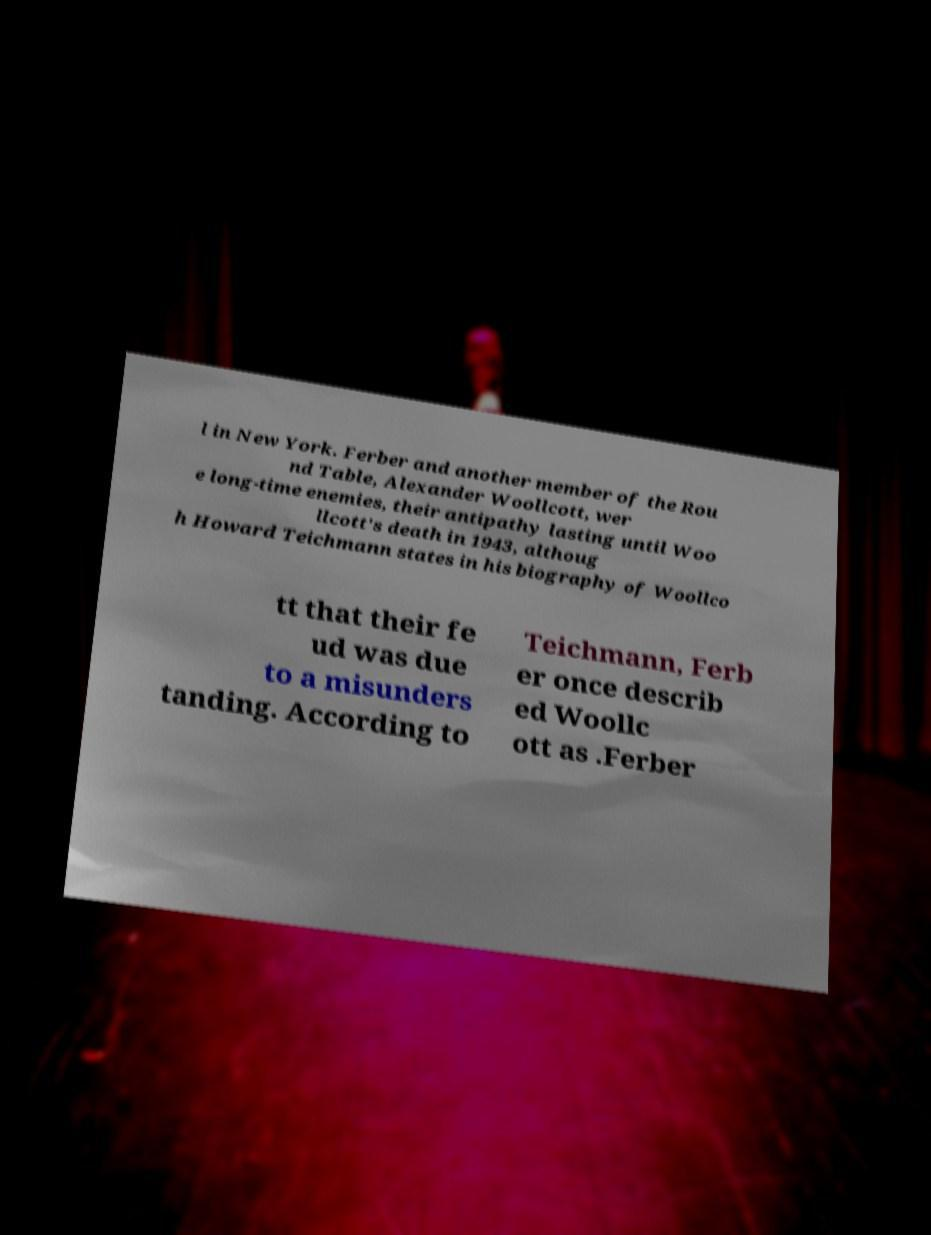Please read and relay the text visible in this image. What does it say? l in New York. Ferber and another member of the Rou nd Table, Alexander Woollcott, wer e long-time enemies, their antipathy lasting until Woo llcott's death in 1943, althoug h Howard Teichmann states in his biography of Woollco tt that their fe ud was due to a misunders tanding. According to Teichmann, Ferb er once describ ed Woollc ott as .Ferber 